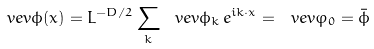<formula> <loc_0><loc_0><loc_500><loc_500>\ v e v { \phi ( x ) } = L ^ { - D / 2 } \sum _ { k } \ v e v { \phi _ { k } } \, e ^ { i k \cdot x } = \ v e v { \varphi _ { 0 } } = \bar { \phi }</formula> 